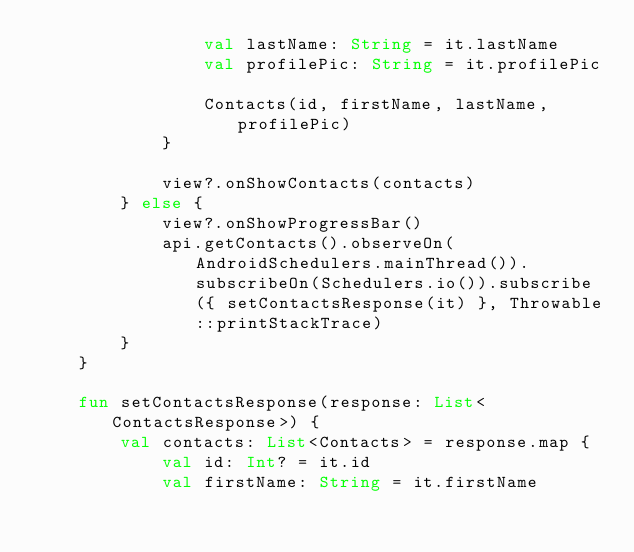Convert code to text. <code><loc_0><loc_0><loc_500><loc_500><_Kotlin_>                val lastName: String = it.lastName
                val profilePic: String = it.profilePic

                Contacts(id, firstName, lastName, profilePic)
            }

            view?.onShowContacts(contacts)
        } else {
            view?.onShowProgressBar()
            api.getContacts().observeOn(AndroidSchedulers.mainThread()).subscribeOn(Schedulers.io()).subscribe({ setContactsResponse(it) }, Throwable::printStackTrace)
        }
    }

    fun setContactsResponse(response: List<ContactsResponse>) {
        val contacts: List<Contacts> = response.map {
            val id: Int? = it.id
            val firstName: String = it.firstName</code> 